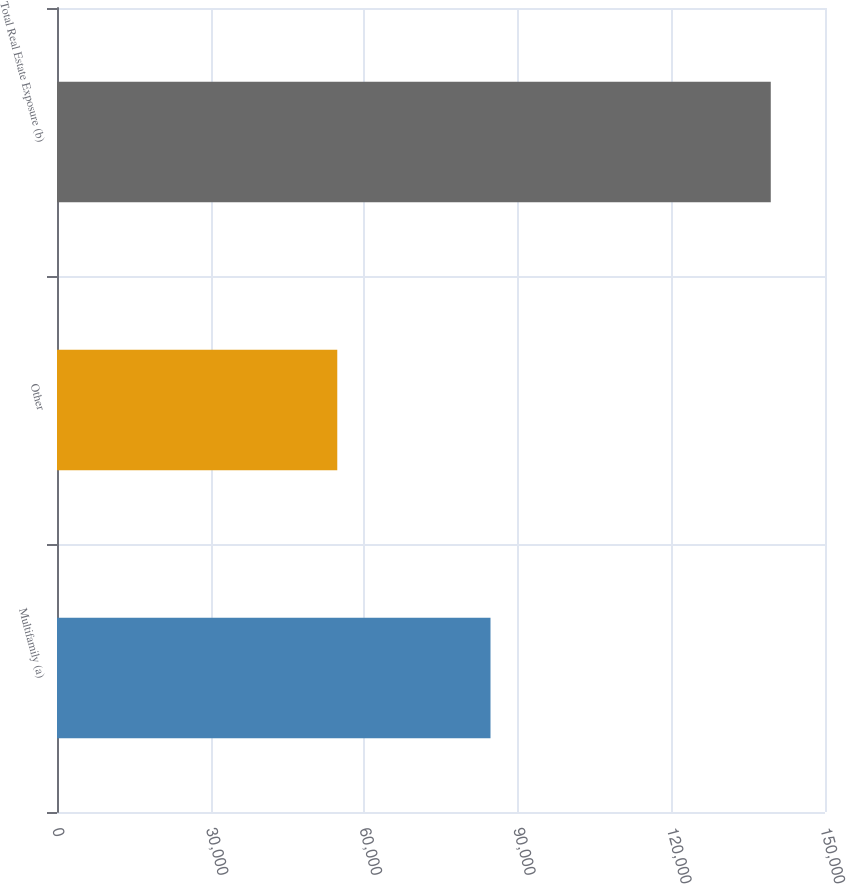Convert chart. <chart><loc_0><loc_0><loc_500><loc_500><bar_chart><fcel>Multifamily (a)<fcel>Other<fcel>Total Real Estate Exposure (b)<nl><fcel>84669<fcel>54740<fcel>139409<nl></chart> 